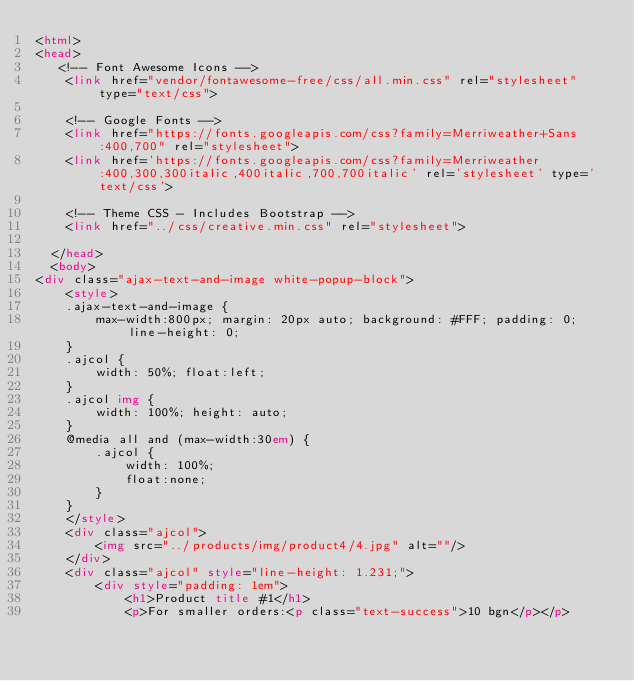<code> <loc_0><loc_0><loc_500><loc_500><_HTML_><html>
<head>
   <!-- Font Awesome Icons -->
    <link href="vendor/fontawesome-free/css/all.min.css" rel="stylesheet" type="text/css">
  
    <!-- Google Fonts -->
    <link href="https://fonts.googleapis.com/css?family=Merriweather+Sans:400,700" rel="stylesheet">
    <link href='https://fonts.googleapis.com/css?family=Merriweather:400,300,300italic,400italic,700,700italic' rel='stylesheet' type='text/css'>
  
    <!-- Theme CSS - Includes Bootstrap -->
    <link href="../css/creative.min.css" rel="stylesheet">
  
  </head>
  <body>
<div class="ajax-text-and-image white-popup-block">
	<style>
	.ajax-text-and-image {
		max-width:800px; margin: 20px auto; background: #FFF; padding: 0; line-height: 0;
	}
	.ajcol {
		width: 50%; float:left;
	}
	.ajcol img {
		width: 100%; height: auto;
	}
	@media all and (max-width:30em) {
		.ajcol { 
			width: 100%;
			float:none;
		}
	}
	</style>
	<div class="ajcol">
		<img src="../products/img/product4/4.jpg" alt=""/>
	</div>
	<div class="ajcol" style="line-height: 1.231;">
		<div style="padding: 1em">
			<h1>Product title #1</h1>
		    <p>For smaller orders:<p class="text-success">10 bgn</p></p></code> 